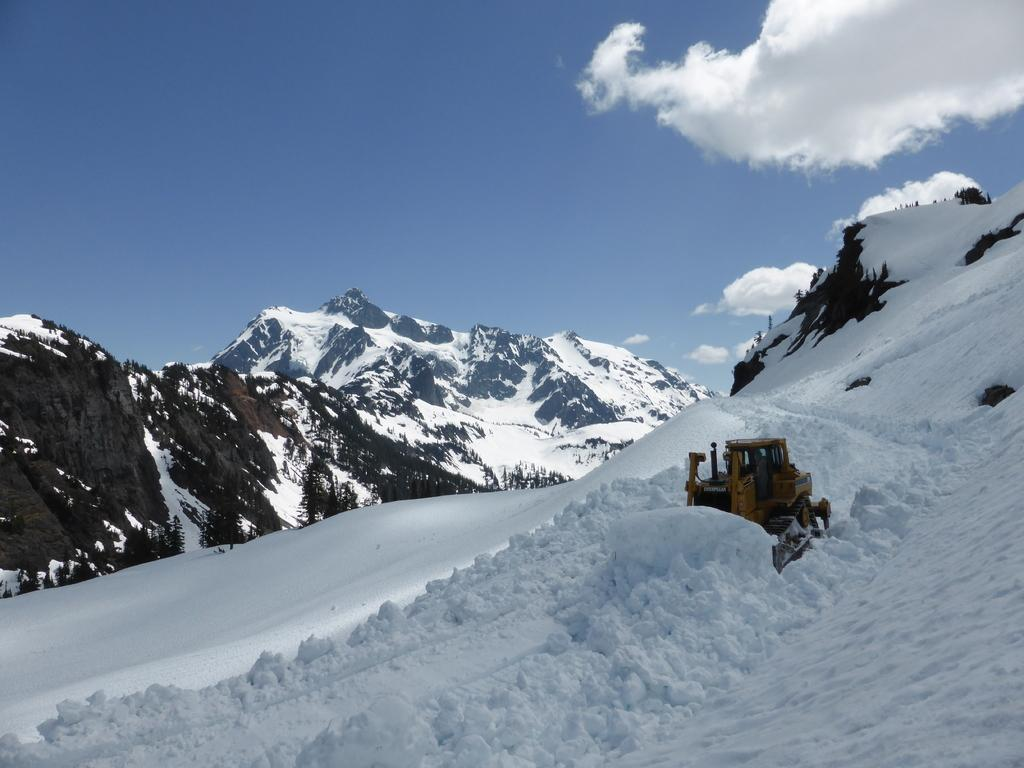What type of vehicle is in the image? There is a bulldozer in the image. What color is the bulldozer? The bulldozer is yellow. What is the weather like in the image? The image shows snow. What can be seen on the left side of the image? There are mountains on the left side of the image. What color is the sky in the image? The sky is blue in the image. How many kittens are sleeping on the beds in the image? There are no kittens or beds present in the image. 